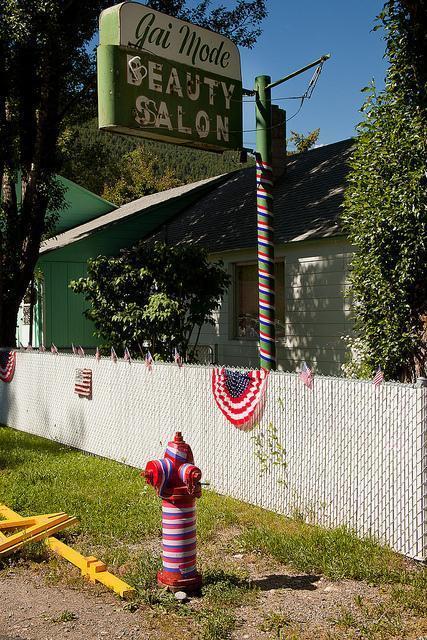How many people and standing to the child's left?
Give a very brief answer. 0. 